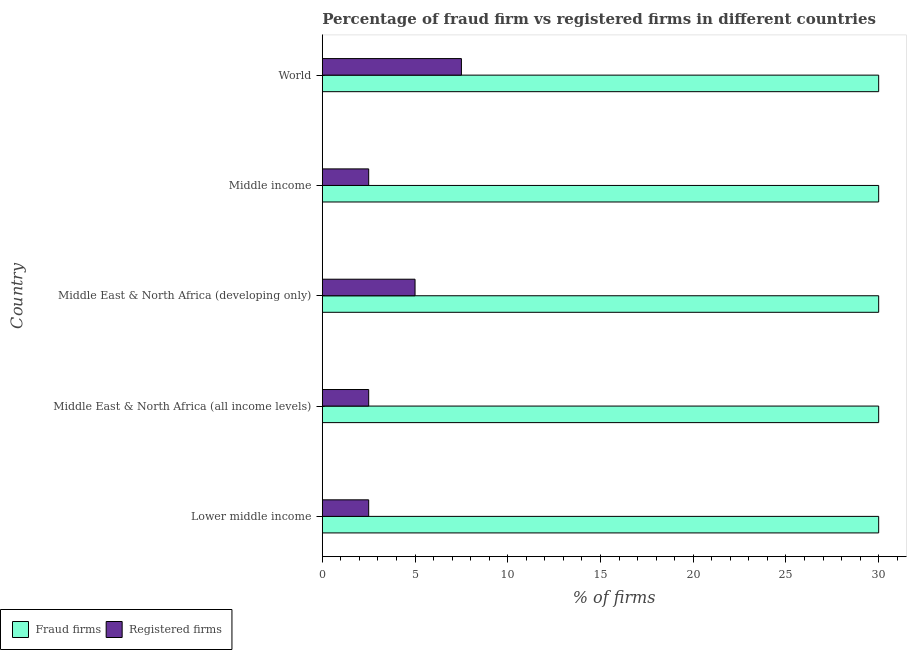How many different coloured bars are there?
Make the answer very short. 2. How many groups of bars are there?
Give a very brief answer. 5. Are the number of bars per tick equal to the number of legend labels?
Offer a very short reply. Yes. What is the label of the 4th group of bars from the top?
Keep it short and to the point. Middle East & North Africa (all income levels). In how many cases, is the number of bars for a given country not equal to the number of legend labels?
Keep it short and to the point. 0. What is the percentage of fraud firms in World?
Provide a succinct answer. 30. Across all countries, what is the maximum percentage of fraud firms?
Your response must be concise. 30. Across all countries, what is the minimum percentage of fraud firms?
Give a very brief answer. 30. In which country was the percentage of registered firms minimum?
Keep it short and to the point. Lower middle income. What is the total percentage of fraud firms in the graph?
Provide a short and direct response. 150. What is the difference between the percentage of fraud firms in Middle income and that in World?
Provide a succinct answer. 0. What is the average percentage of fraud firms per country?
Keep it short and to the point. 30. Is the difference between the percentage of registered firms in Middle East & North Africa (developing only) and World greater than the difference between the percentage of fraud firms in Middle East & North Africa (developing only) and World?
Your answer should be very brief. No. In how many countries, is the percentage of fraud firms greater than the average percentage of fraud firms taken over all countries?
Make the answer very short. 0. Is the sum of the percentage of registered firms in Lower middle income and Middle income greater than the maximum percentage of fraud firms across all countries?
Offer a terse response. No. What does the 2nd bar from the top in Lower middle income represents?
Your answer should be compact. Fraud firms. What does the 1st bar from the bottom in Middle East & North Africa (all income levels) represents?
Ensure brevity in your answer.  Fraud firms. How many bars are there?
Keep it short and to the point. 10. How many countries are there in the graph?
Your answer should be very brief. 5. What is the difference between two consecutive major ticks on the X-axis?
Make the answer very short. 5. Are the values on the major ticks of X-axis written in scientific E-notation?
Provide a short and direct response. No. Does the graph contain any zero values?
Your response must be concise. No. What is the title of the graph?
Offer a very short reply. Percentage of fraud firm vs registered firms in different countries. What is the label or title of the X-axis?
Offer a terse response. % of firms. What is the % of firms of Registered firms in Lower middle income?
Provide a short and direct response. 2.5. What is the % of firms in Fraud firms in Middle East & North Africa (all income levels)?
Make the answer very short. 30. What is the % of firms of Fraud firms in World?
Keep it short and to the point. 30. What is the % of firms in Registered firms in World?
Ensure brevity in your answer.  7.5. Across all countries, what is the maximum % of firms of Fraud firms?
Provide a short and direct response. 30. Across all countries, what is the minimum % of firms in Fraud firms?
Give a very brief answer. 30. What is the total % of firms in Fraud firms in the graph?
Your response must be concise. 150. What is the total % of firms in Registered firms in the graph?
Provide a succinct answer. 20. What is the difference between the % of firms in Fraud firms in Lower middle income and that in Middle East & North Africa (developing only)?
Make the answer very short. 0. What is the difference between the % of firms in Registered firms in Lower middle income and that in Middle East & North Africa (developing only)?
Offer a terse response. -2.5. What is the difference between the % of firms in Fraud firms in Lower middle income and that in World?
Your answer should be compact. 0. What is the difference between the % of firms of Fraud firms in Middle East & North Africa (all income levels) and that in Middle East & North Africa (developing only)?
Keep it short and to the point. 0. What is the difference between the % of firms of Fraud firms in Middle East & North Africa (all income levels) and that in World?
Provide a succinct answer. 0. What is the difference between the % of firms in Fraud firms in Middle East & North Africa (developing only) and that in Middle income?
Give a very brief answer. 0. What is the difference between the % of firms of Registered firms in Middle East & North Africa (developing only) and that in World?
Give a very brief answer. -2.5. What is the difference between the % of firms in Fraud firms in Middle income and that in World?
Offer a terse response. 0. What is the difference between the % of firms in Fraud firms in Lower middle income and the % of firms in Registered firms in World?
Ensure brevity in your answer.  22.5. What is the difference between the % of firms in Fraud firms in Middle East & North Africa (all income levels) and the % of firms in Registered firms in Middle East & North Africa (developing only)?
Offer a very short reply. 25. What is the difference between the % of firms of Fraud firms in Middle East & North Africa (developing only) and the % of firms of Registered firms in Middle income?
Your response must be concise. 27.5. What is the average % of firms in Fraud firms per country?
Offer a very short reply. 30. What is the average % of firms in Registered firms per country?
Give a very brief answer. 4. What is the difference between the % of firms of Fraud firms and % of firms of Registered firms in Lower middle income?
Provide a short and direct response. 27.5. What is the difference between the % of firms of Fraud firms and % of firms of Registered firms in Middle East & North Africa (developing only)?
Your answer should be very brief. 25. What is the difference between the % of firms of Fraud firms and % of firms of Registered firms in World?
Provide a short and direct response. 22.5. What is the ratio of the % of firms of Fraud firms in Lower middle income to that in Middle income?
Ensure brevity in your answer.  1. What is the ratio of the % of firms of Registered firms in Lower middle income to that in Middle income?
Provide a succinct answer. 1. What is the ratio of the % of firms in Fraud firms in Middle East & North Africa (all income levels) to that in Middle income?
Provide a short and direct response. 1. What is the ratio of the % of firms in Fraud firms in Middle East & North Africa (all income levels) to that in World?
Offer a very short reply. 1. What is the ratio of the % of firms of Registered firms in Middle East & North Africa (all income levels) to that in World?
Ensure brevity in your answer.  0.33. What is the ratio of the % of firms of Fraud firms in Middle East & North Africa (developing only) to that in Middle income?
Offer a terse response. 1. What is the ratio of the % of firms of Registered firms in Middle East & North Africa (developing only) to that in Middle income?
Ensure brevity in your answer.  2. What is the ratio of the % of firms in Fraud firms in Middle East & North Africa (developing only) to that in World?
Offer a very short reply. 1. What is the ratio of the % of firms in Fraud firms in Middle income to that in World?
Offer a terse response. 1. What is the difference between the highest and the second highest % of firms in Fraud firms?
Make the answer very short. 0. What is the difference between the highest and the second highest % of firms of Registered firms?
Make the answer very short. 2.5. What is the difference between the highest and the lowest % of firms in Fraud firms?
Your answer should be very brief. 0. 